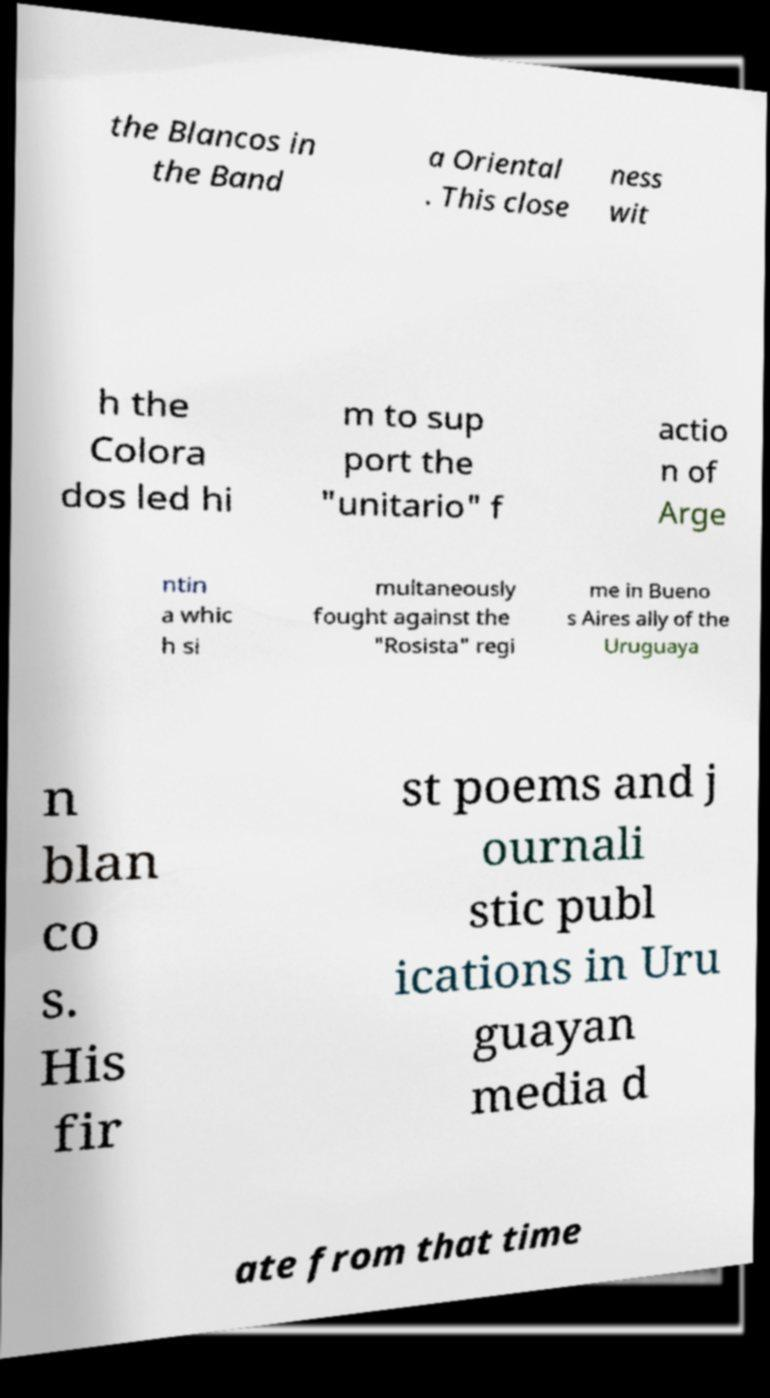What messages or text are displayed in this image? I need them in a readable, typed format. the Blancos in the Band a Oriental . This close ness wit h the Colora dos led hi m to sup port the "unitario" f actio n of Arge ntin a whic h si multaneously fought against the "Rosista" regi me in Bueno s Aires ally of the Uruguaya n blan co s. His fir st poems and j ournali stic publ ications in Uru guayan media d ate from that time 